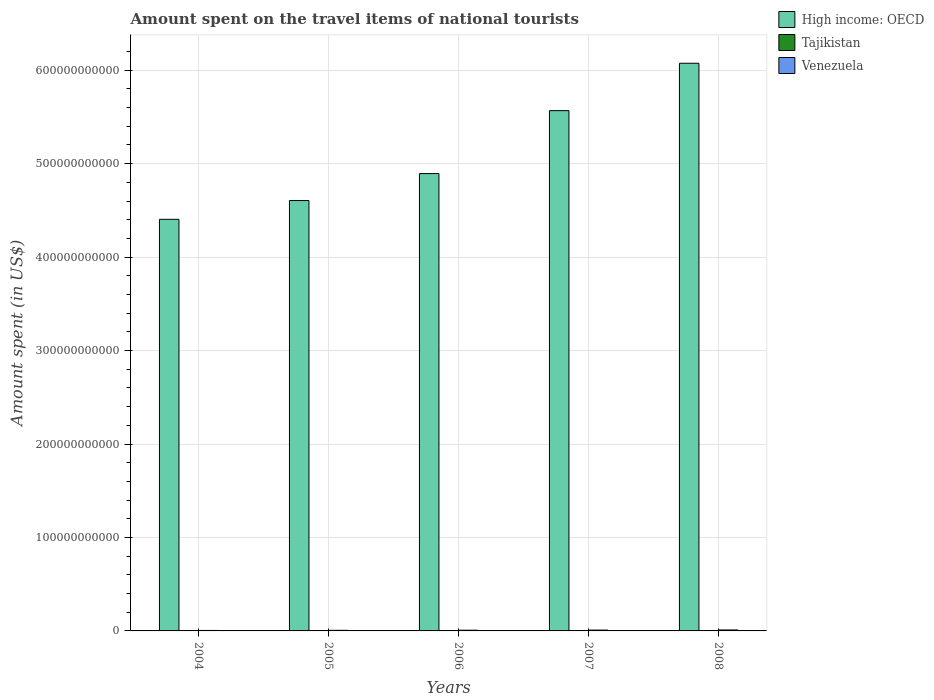How many different coloured bars are there?
Ensure brevity in your answer.  3. How many groups of bars are there?
Offer a terse response. 5. Are the number of bars per tick equal to the number of legend labels?
Ensure brevity in your answer.  Yes. Are the number of bars on each tick of the X-axis equal?
Keep it short and to the point. Yes. How many bars are there on the 5th tick from the right?
Give a very brief answer. 3. What is the amount spent on the travel items of national tourists in Venezuela in 2005?
Provide a succinct answer. 6.50e+08. Across all years, what is the maximum amount spent on the travel items of national tourists in Venezuela?
Your answer should be compact. 1.03e+09. Across all years, what is the minimum amount spent on the travel items of national tourists in Venezuela?
Your response must be concise. 5.02e+08. What is the total amount spent on the travel items of national tourists in Venezuela in the graph?
Your answer should be compact. 3.84e+09. What is the difference between the amount spent on the travel items of national tourists in Tajikistan in 2005 and that in 2008?
Your response must be concise. -2.60e+06. What is the difference between the amount spent on the travel items of national tourists in Tajikistan in 2007 and the amount spent on the travel items of national tourists in Venezuela in 2005?
Give a very brief answer. -6.47e+08. What is the average amount spent on the travel items of national tourists in Venezuela per year?
Offer a very short reply. 7.69e+08. In the year 2005, what is the difference between the amount spent on the travel items of national tourists in High income: OECD and amount spent on the travel items of national tourists in Tajikistan?
Offer a very short reply. 4.61e+11. In how many years, is the amount spent on the travel items of national tourists in Venezuela greater than 20000000000 US$?
Your response must be concise. 0. What is the ratio of the amount spent on the travel items of national tourists in Venezuela in 2005 to that in 2006?
Ensure brevity in your answer.  0.85. Is the amount spent on the travel items of national tourists in Venezuela in 2005 less than that in 2007?
Your answer should be compact. Yes. Is the difference between the amount spent on the travel items of national tourists in High income: OECD in 2007 and 2008 greater than the difference between the amount spent on the travel items of national tourists in Tajikistan in 2007 and 2008?
Provide a short and direct response. No. What is the difference between the highest and the second highest amount spent on the travel items of national tourists in High income: OECD?
Provide a succinct answer. 5.07e+1. In how many years, is the amount spent on the travel items of national tourists in High income: OECD greater than the average amount spent on the travel items of national tourists in High income: OECD taken over all years?
Offer a very short reply. 2. Is the sum of the amount spent on the travel items of national tourists in High income: OECD in 2005 and 2007 greater than the maximum amount spent on the travel items of national tourists in Tajikistan across all years?
Make the answer very short. Yes. What does the 3rd bar from the left in 2007 represents?
Make the answer very short. Venezuela. What does the 2nd bar from the right in 2005 represents?
Ensure brevity in your answer.  Tajikistan. How many bars are there?
Your answer should be compact. 15. Are all the bars in the graph horizontal?
Provide a short and direct response. No. How many years are there in the graph?
Offer a terse response. 5. What is the difference between two consecutive major ticks on the Y-axis?
Provide a short and direct response. 1.00e+11. Does the graph contain grids?
Your answer should be compact. Yes. How many legend labels are there?
Ensure brevity in your answer.  3. How are the legend labels stacked?
Ensure brevity in your answer.  Vertical. What is the title of the graph?
Your answer should be compact. Amount spent on the travel items of national tourists. What is the label or title of the X-axis?
Your response must be concise. Years. What is the label or title of the Y-axis?
Provide a short and direct response. Amount spent (in US$). What is the Amount spent (in US$) in High income: OECD in 2004?
Offer a terse response. 4.40e+11. What is the Amount spent (in US$) of Tajikistan in 2004?
Keep it short and to the point. 1.20e+06. What is the Amount spent (in US$) of Venezuela in 2004?
Your response must be concise. 5.02e+08. What is the Amount spent (in US$) of High income: OECD in 2005?
Give a very brief answer. 4.61e+11. What is the Amount spent (in US$) of Tajikistan in 2005?
Give a very brief answer. 1.60e+06. What is the Amount spent (in US$) in Venezuela in 2005?
Keep it short and to the point. 6.50e+08. What is the Amount spent (in US$) of High income: OECD in 2006?
Offer a terse response. 4.89e+11. What is the Amount spent (in US$) in Tajikistan in 2006?
Provide a short and direct response. 2.10e+06. What is the Amount spent (in US$) in Venezuela in 2006?
Offer a terse response. 7.68e+08. What is the Amount spent (in US$) of High income: OECD in 2007?
Your response must be concise. 5.57e+11. What is the Amount spent (in US$) in Tajikistan in 2007?
Keep it short and to the point. 3.30e+06. What is the Amount spent (in US$) of Venezuela in 2007?
Offer a terse response. 8.95e+08. What is the Amount spent (in US$) in High income: OECD in 2008?
Give a very brief answer. 6.07e+11. What is the Amount spent (in US$) in Tajikistan in 2008?
Your response must be concise. 4.20e+06. What is the Amount spent (in US$) in Venezuela in 2008?
Make the answer very short. 1.03e+09. Across all years, what is the maximum Amount spent (in US$) in High income: OECD?
Your answer should be very brief. 6.07e+11. Across all years, what is the maximum Amount spent (in US$) of Tajikistan?
Keep it short and to the point. 4.20e+06. Across all years, what is the maximum Amount spent (in US$) in Venezuela?
Offer a very short reply. 1.03e+09. Across all years, what is the minimum Amount spent (in US$) of High income: OECD?
Make the answer very short. 4.40e+11. Across all years, what is the minimum Amount spent (in US$) of Tajikistan?
Keep it short and to the point. 1.20e+06. Across all years, what is the minimum Amount spent (in US$) of Venezuela?
Give a very brief answer. 5.02e+08. What is the total Amount spent (in US$) in High income: OECD in the graph?
Your response must be concise. 2.55e+12. What is the total Amount spent (in US$) in Tajikistan in the graph?
Offer a terse response. 1.24e+07. What is the total Amount spent (in US$) of Venezuela in the graph?
Keep it short and to the point. 3.84e+09. What is the difference between the Amount spent (in US$) in High income: OECD in 2004 and that in 2005?
Provide a short and direct response. -2.01e+1. What is the difference between the Amount spent (in US$) in Tajikistan in 2004 and that in 2005?
Provide a short and direct response. -4.00e+05. What is the difference between the Amount spent (in US$) in Venezuela in 2004 and that in 2005?
Your answer should be very brief. -1.48e+08. What is the difference between the Amount spent (in US$) in High income: OECD in 2004 and that in 2006?
Your answer should be very brief. -4.90e+1. What is the difference between the Amount spent (in US$) of Tajikistan in 2004 and that in 2006?
Offer a very short reply. -9.00e+05. What is the difference between the Amount spent (in US$) of Venezuela in 2004 and that in 2006?
Make the answer very short. -2.66e+08. What is the difference between the Amount spent (in US$) in High income: OECD in 2004 and that in 2007?
Your response must be concise. -1.16e+11. What is the difference between the Amount spent (in US$) in Tajikistan in 2004 and that in 2007?
Your answer should be very brief. -2.10e+06. What is the difference between the Amount spent (in US$) of Venezuela in 2004 and that in 2007?
Your answer should be compact. -3.93e+08. What is the difference between the Amount spent (in US$) of High income: OECD in 2004 and that in 2008?
Provide a succinct answer. -1.67e+11. What is the difference between the Amount spent (in US$) of Venezuela in 2004 and that in 2008?
Make the answer very short. -5.28e+08. What is the difference between the Amount spent (in US$) in High income: OECD in 2005 and that in 2006?
Your response must be concise. -2.89e+1. What is the difference between the Amount spent (in US$) of Tajikistan in 2005 and that in 2006?
Make the answer very short. -5.00e+05. What is the difference between the Amount spent (in US$) of Venezuela in 2005 and that in 2006?
Your response must be concise. -1.18e+08. What is the difference between the Amount spent (in US$) in High income: OECD in 2005 and that in 2007?
Offer a terse response. -9.62e+1. What is the difference between the Amount spent (in US$) of Tajikistan in 2005 and that in 2007?
Provide a short and direct response. -1.70e+06. What is the difference between the Amount spent (in US$) of Venezuela in 2005 and that in 2007?
Ensure brevity in your answer.  -2.45e+08. What is the difference between the Amount spent (in US$) of High income: OECD in 2005 and that in 2008?
Provide a short and direct response. -1.47e+11. What is the difference between the Amount spent (in US$) of Tajikistan in 2005 and that in 2008?
Make the answer very short. -2.60e+06. What is the difference between the Amount spent (in US$) in Venezuela in 2005 and that in 2008?
Offer a terse response. -3.80e+08. What is the difference between the Amount spent (in US$) in High income: OECD in 2006 and that in 2007?
Your response must be concise. -6.73e+1. What is the difference between the Amount spent (in US$) of Tajikistan in 2006 and that in 2007?
Your answer should be compact. -1.20e+06. What is the difference between the Amount spent (in US$) in Venezuela in 2006 and that in 2007?
Provide a succinct answer. -1.27e+08. What is the difference between the Amount spent (in US$) of High income: OECD in 2006 and that in 2008?
Ensure brevity in your answer.  -1.18e+11. What is the difference between the Amount spent (in US$) in Tajikistan in 2006 and that in 2008?
Offer a terse response. -2.10e+06. What is the difference between the Amount spent (in US$) of Venezuela in 2006 and that in 2008?
Offer a very short reply. -2.62e+08. What is the difference between the Amount spent (in US$) in High income: OECD in 2007 and that in 2008?
Your response must be concise. -5.07e+1. What is the difference between the Amount spent (in US$) in Tajikistan in 2007 and that in 2008?
Give a very brief answer. -9.00e+05. What is the difference between the Amount spent (in US$) in Venezuela in 2007 and that in 2008?
Your response must be concise. -1.35e+08. What is the difference between the Amount spent (in US$) of High income: OECD in 2004 and the Amount spent (in US$) of Tajikistan in 2005?
Give a very brief answer. 4.40e+11. What is the difference between the Amount spent (in US$) in High income: OECD in 2004 and the Amount spent (in US$) in Venezuela in 2005?
Ensure brevity in your answer.  4.40e+11. What is the difference between the Amount spent (in US$) in Tajikistan in 2004 and the Amount spent (in US$) in Venezuela in 2005?
Make the answer very short. -6.49e+08. What is the difference between the Amount spent (in US$) of High income: OECD in 2004 and the Amount spent (in US$) of Tajikistan in 2006?
Provide a succinct answer. 4.40e+11. What is the difference between the Amount spent (in US$) in High income: OECD in 2004 and the Amount spent (in US$) in Venezuela in 2006?
Provide a succinct answer. 4.40e+11. What is the difference between the Amount spent (in US$) of Tajikistan in 2004 and the Amount spent (in US$) of Venezuela in 2006?
Provide a succinct answer. -7.67e+08. What is the difference between the Amount spent (in US$) of High income: OECD in 2004 and the Amount spent (in US$) of Tajikistan in 2007?
Make the answer very short. 4.40e+11. What is the difference between the Amount spent (in US$) of High income: OECD in 2004 and the Amount spent (in US$) of Venezuela in 2007?
Keep it short and to the point. 4.40e+11. What is the difference between the Amount spent (in US$) of Tajikistan in 2004 and the Amount spent (in US$) of Venezuela in 2007?
Your answer should be very brief. -8.94e+08. What is the difference between the Amount spent (in US$) of High income: OECD in 2004 and the Amount spent (in US$) of Tajikistan in 2008?
Provide a succinct answer. 4.40e+11. What is the difference between the Amount spent (in US$) of High income: OECD in 2004 and the Amount spent (in US$) of Venezuela in 2008?
Make the answer very short. 4.39e+11. What is the difference between the Amount spent (in US$) in Tajikistan in 2004 and the Amount spent (in US$) in Venezuela in 2008?
Offer a terse response. -1.03e+09. What is the difference between the Amount spent (in US$) of High income: OECD in 2005 and the Amount spent (in US$) of Tajikistan in 2006?
Your answer should be compact. 4.61e+11. What is the difference between the Amount spent (in US$) in High income: OECD in 2005 and the Amount spent (in US$) in Venezuela in 2006?
Your answer should be compact. 4.60e+11. What is the difference between the Amount spent (in US$) in Tajikistan in 2005 and the Amount spent (in US$) in Venezuela in 2006?
Ensure brevity in your answer.  -7.66e+08. What is the difference between the Amount spent (in US$) in High income: OECD in 2005 and the Amount spent (in US$) in Tajikistan in 2007?
Give a very brief answer. 4.61e+11. What is the difference between the Amount spent (in US$) of High income: OECD in 2005 and the Amount spent (in US$) of Venezuela in 2007?
Keep it short and to the point. 4.60e+11. What is the difference between the Amount spent (in US$) in Tajikistan in 2005 and the Amount spent (in US$) in Venezuela in 2007?
Offer a terse response. -8.93e+08. What is the difference between the Amount spent (in US$) in High income: OECD in 2005 and the Amount spent (in US$) in Tajikistan in 2008?
Provide a succinct answer. 4.61e+11. What is the difference between the Amount spent (in US$) in High income: OECD in 2005 and the Amount spent (in US$) in Venezuela in 2008?
Keep it short and to the point. 4.60e+11. What is the difference between the Amount spent (in US$) of Tajikistan in 2005 and the Amount spent (in US$) of Venezuela in 2008?
Offer a terse response. -1.03e+09. What is the difference between the Amount spent (in US$) in High income: OECD in 2006 and the Amount spent (in US$) in Tajikistan in 2007?
Keep it short and to the point. 4.89e+11. What is the difference between the Amount spent (in US$) of High income: OECD in 2006 and the Amount spent (in US$) of Venezuela in 2007?
Make the answer very short. 4.89e+11. What is the difference between the Amount spent (in US$) of Tajikistan in 2006 and the Amount spent (in US$) of Venezuela in 2007?
Your answer should be compact. -8.93e+08. What is the difference between the Amount spent (in US$) of High income: OECD in 2006 and the Amount spent (in US$) of Tajikistan in 2008?
Offer a very short reply. 4.89e+11. What is the difference between the Amount spent (in US$) of High income: OECD in 2006 and the Amount spent (in US$) of Venezuela in 2008?
Give a very brief answer. 4.88e+11. What is the difference between the Amount spent (in US$) in Tajikistan in 2006 and the Amount spent (in US$) in Venezuela in 2008?
Give a very brief answer. -1.03e+09. What is the difference between the Amount spent (in US$) in High income: OECD in 2007 and the Amount spent (in US$) in Tajikistan in 2008?
Make the answer very short. 5.57e+11. What is the difference between the Amount spent (in US$) in High income: OECD in 2007 and the Amount spent (in US$) in Venezuela in 2008?
Make the answer very short. 5.56e+11. What is the difference between the Amount spent (in US$) in Tajikistan in 2007 and the Amount spent (in US$) in Venezuela in 2008?
Provide a short and direct response. -1.03e+09. What is the average Amount spent (in US$) of High income: OECD per year?
Keep it short and to the point. 5.11e+11. What is the average Amount spent (in US$) in Tajikistan per year?
Give a very brief answer. 2.48e+06. What is the average Amount spent (in US$) in Venezuela per year?
Offer a terse response. 7.69e+08. In the year 2004, what is the difference between the Amount spent (in US$) of High income: OECD and Amount spent (in US$) of Tajikistan?
Give a very brief answer. 4.40e+11. In the year 2004, what is the difference between the Amount spent (in US$) of High income: OECD and Amount spent (in US$) of Venezuela?
Keep it short and to the point. 4.40e+11. In the year 2004, what is the difference between the Amount spent (in US$) in Tajikistan and Amount spent (in US$) in Venezuela?
Provide a short and direct response. -5.01e+08. In the year 2005, what is the difference between the Amount spent (in US$) in High income: OECD and Amount spent (in US$) in Tajikistan?
Give a very brief answer. 4.61e+11. In the year 2005, what is the difference between the Amount spent (in US$) in High income: OECD and Amount spent (in US$) in Venezuela?
Your response must be concise. 4.60e+11. In the year 2005, what is the difference between the Amount spent (in US$) in Tajikistan and Amount spent (in US$) in Venezuela?
Keep it short and to the point. -6.48e+08. In the year 2006, what is the difference between the Amount spent (in US$) of High income: OECD and Amount spent (in US$) of Tajikistan?
Your response must be concise. 4.89e+11. In the year 2006, what is the difference between the Amount spent (in US$) of High income: OECD and Amount spent (in US$) of Venezuela?
Your answer should be compact. 4.89e+11. In the year 2006, what is the difference between the Amount spent (in US$) in Tajikistan and Amount spent (in US$) in Venezuela?
Give a very brief answer. -7.66e+08. In the year 2007, what is the difference between the Amount spent (in US$) in High income: OECD and Amount spent (in US$) in Tajikistan?
Ensure brevity in your answer.  5.57e+11. In the year 2007, what is the difference between the Amount spent (in US$) of High income: OECD and Amount spent (in US$) of Venezuela?
Give a very brief answer. 5.56e+11. In the year 2007, what is the difference between the Amount spent (in US$) in Tajikistan and Amount spent (in US$) in Venezuela?
Your response must be concise. -8.92e+08. In the year 2008, what is the difference between the Amount spent (in US$) of High income: OECD and Amount spent (in US$) of Tajikistan?
Make the answer very short. 6.07e+11. In the year 2008, what is the difference between the Amount spent (in US$) of High income: OECD and Amount spent (in US$) of Venezuela?
Your answer should be very brief. 6.06e+11. In the year 2008, what is the difference between the Amount spent (in US$) in Tajikistan and Amount spent (in US$) in Venezuela?
Your answer should be very brief. -1.03e+09. What is the ratio of the Amount spent (in US$) of High income: OECD in 2004 to that in 2005?
Make the answer very short. 0.96. What is the ratio of the Amount spent (in US$) in Tajikistan in 2004 to that in 2005?
Ensure brevity in your answer.  0.75. What is the ratio of the Amount spent (in US$) of Venezuela in 2004 to that in 2005?
Keep it short and to the point. 0.77. What is the ratio of the Amount spent (in US$) of Tajikistan in 2004 to that in 2006?
Your response must be concise. 0.57. What is the ratio of the Amount spent (in US$) of Venezuela in 2004 to that in 2006?
Make the answer very short. 0.65. What is the ratio of the Amount spent (in US$) in High income: OECD in 2004 to that in 2007?
Your answer should be compact. 0.79. What is the ratio of the Amount spent (in US$) of Tajikistan in 2004 to that in 2007?
Your answer should be compact. 0.36. What is the ratio of the Amount spent (in US$) of Venezuela in 2004 to that in 2007?
Your response must be concise. 0.56. What is the ratio of the Amount spent (in US$) in High income: OECD in 2004 to that in 2008?
Keep it short and to the point. 0.73. What is the ratio of the Amount spent (in US$) of Tajikistan in 2004 to that in 2008?
Ensure brevity in your answer.  0.29. What is the ratio of the Amount spent (in US$) in Venezuela in 2004 to that in 2008?
Give a very brief answer. 0.49. What is the ratio of the Amount spent (in US$) of High income: OECD in 2005 to that in 2006?
Ensure brevity in your answer.  0.94. What is the ratio of the Amount spent (in US$) in Tajikistan in 2005 to that in 2006?
Ensure brevity in your answer.  0.76. What is the ratio of the Amount spent (in US$) in Venezuela in 2005 to that in 2006?
Provide a short and direct response. 0.85. What is the ratio of the Amount spent (in US$) in High income: OECD in 2005 to that in 2007?
Give a very brief answer. 0.83. What is the ratio of the Amount spent (in US$) in Tajikistan in 2005 to that in 2007?
Make the answer very short. 0.48. What is the ratio of the Amount spent (in US$) of Venezuela in 2005 to that in 2007?
Your answer should be compact. 0.73. What is the ratio of the Amount spent (in US$) in High income: OECD in 2005 to that in 2008?
Provide a short and direct response. 0.76. What is the ratio of the Amount spent (in US$) of Tajikistan in 2005 to that in 2008?
Give a very brief answer. 0.38. What is the ratio of the Amount spent (in US$) in Venezuela in 2005 to that in 2008?
Ensure brevity in your answer.  0.63. What is the ratio of the Amount spent (in US$) of High income: OECD in 2006 to that in 2007?
Offer a very short reply. 0.88. What is the ratio of the Amount spent (in US$) of Tajikistan in 2006 to that in 2007?
Offer a terse response. 0.64. What is the ratio of the Amount spent (in US$) of Venezuela in 2006 to that in 2007?
Your response must be concise. 0.86. What is the ratio of the Amount spent (in US$) of High income: OECD in 2006 to that in 2008?
Make the answer very short. 0.81. What is the ratio of the Amount spent (in US$) of Tajikistan in 2006 to that in 2008?
Give a very brief answer. 0.5. What is the ratio of the Amount spent (in US$) of Venezuela in 2006 to that in 2008?
Offer a terse response. 0.75. What is the ratio of the Amount spent (in US$) of High income: OECD in 2007 to that in 2008?
Keep it short and to the point. 0.92. What is the ratio of the Amount spent (in US$) of Tajikistan in 2007 to that in 2008?
Make the answer very short. 0.79. What is the ratio of the Amount spent (in US$) in Venezuela in 2007 to that in 2008?
Your answer should be compact. 0.87. What is the difference between the highest and the second highest Amount spent (in US$) of High income: OECD?
Ensure brevity in your answer.  5.07e+1. What is the difference between the highest and the second highest Amount spent (in US$) in Venezuela?
Your response must be concise. 1.35e+08. What is the difference between the highest and the lowest Amount spent (in US$) in High income: OECD?
Provide a succinct answer. 1.67e+11. What is the difference between the highest and the lowest Amount spent (in US$) of Venezuela?
Your answer should be very brief. 5.28e+08. 